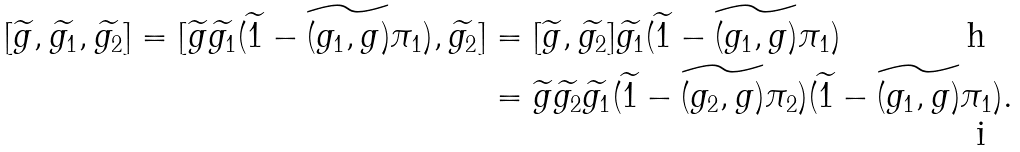Convert formula to latex. <formula><loc_0><loc_0><loc_500><loc_500>[ \widetilde { g } , \widetilde { g _ { 1 } } , \widetilde { g _ { 2 } } ] = [ \widetilde { g } \widetilde { g _ { 1 } } ( \widetilde { 1 } - \widetilde { ( g _ { 1 } , g ) } \pi _ { 1 } ) , \widetilde { g _ { 2 } } ] & = [ \widetilde { g } , \widetilde { g _ { 2 } } ] \widetilde { g _ { 1 } } ( \widetilde { 1 } - \widetilde { ( g _ { 1 } , g ) } \pi _ { 1 } ) \\ & = \widetilde { g } \widetilde { g _ { 2 } } \widetilde { g _ { 1 } } ( \widetilde { 1 } - \widetilde { ( g _ { 2 } , g ) } \pi _ { 2 } ) ( \widetilde { 1 } - \widetilde { ( g _ { 1 } , g ) } \pi _ { 1 } ) .</formula> 